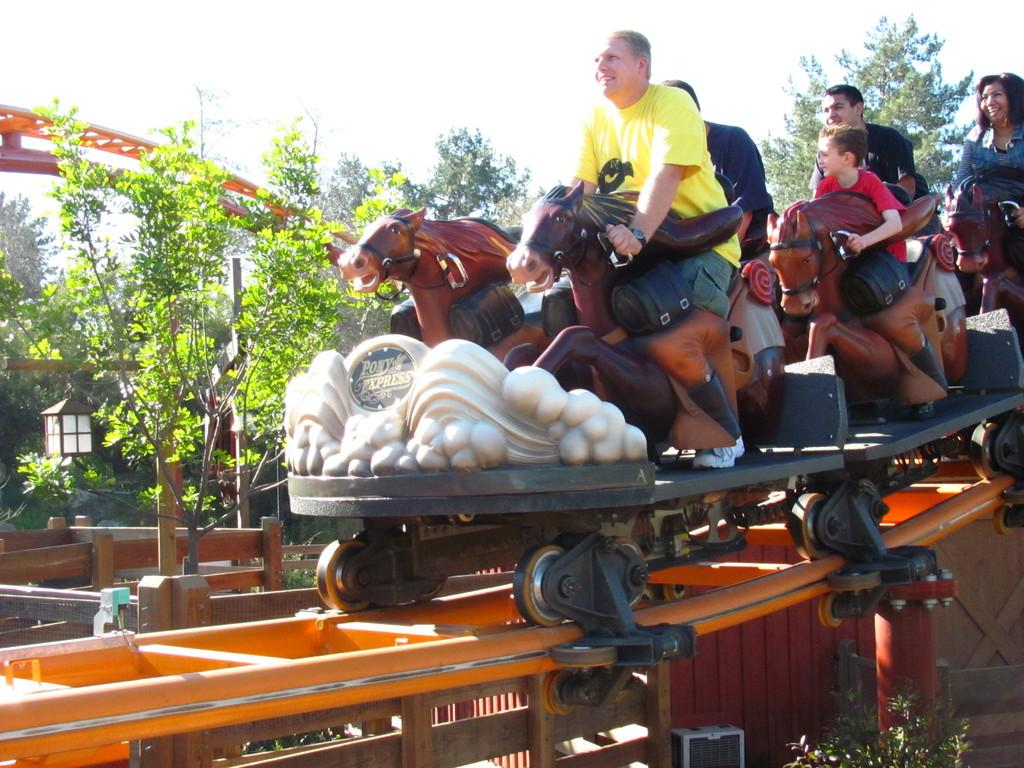What are the people in the image doing? The persons in the image are sitting on the roller coaster. What can be seen in the background of the image? There is a tree and the sky visible in the background of the image. What type of detail can be seen on the roller coaster in the image? There is no specific detail mentioned on the roller coaster in the provided facts, so it cannot be determined from the image. 